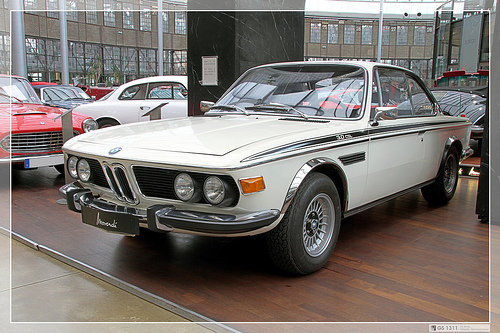<image>
Is the car behind the building? Yes. From this viewpoint, the car is positioned behind the building, with the building partially or fully occluding the car. Is there a wheel behind the car? No. The wheel is not behind the car. From this viewpoint, the wheel appears to be positioned elsewhere in the scene. Is the car to the right of the car? Yes. From this viewpoint, the car is positioned to the right side relative to the car. 